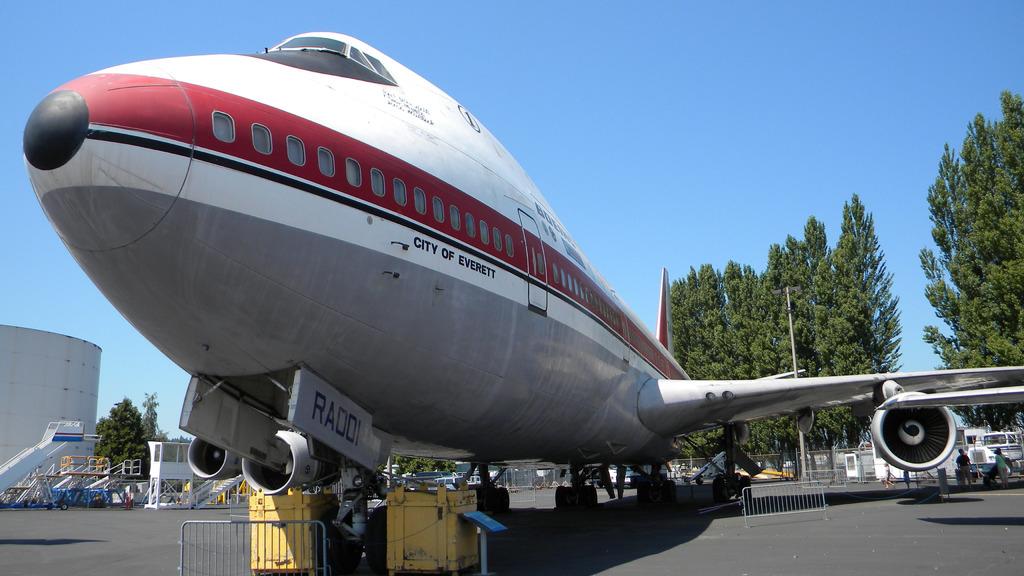What city does this plane belong to?
Your response must be concise. Everett. What is written in blue letters?
Offer a very short reply. Raddi. 